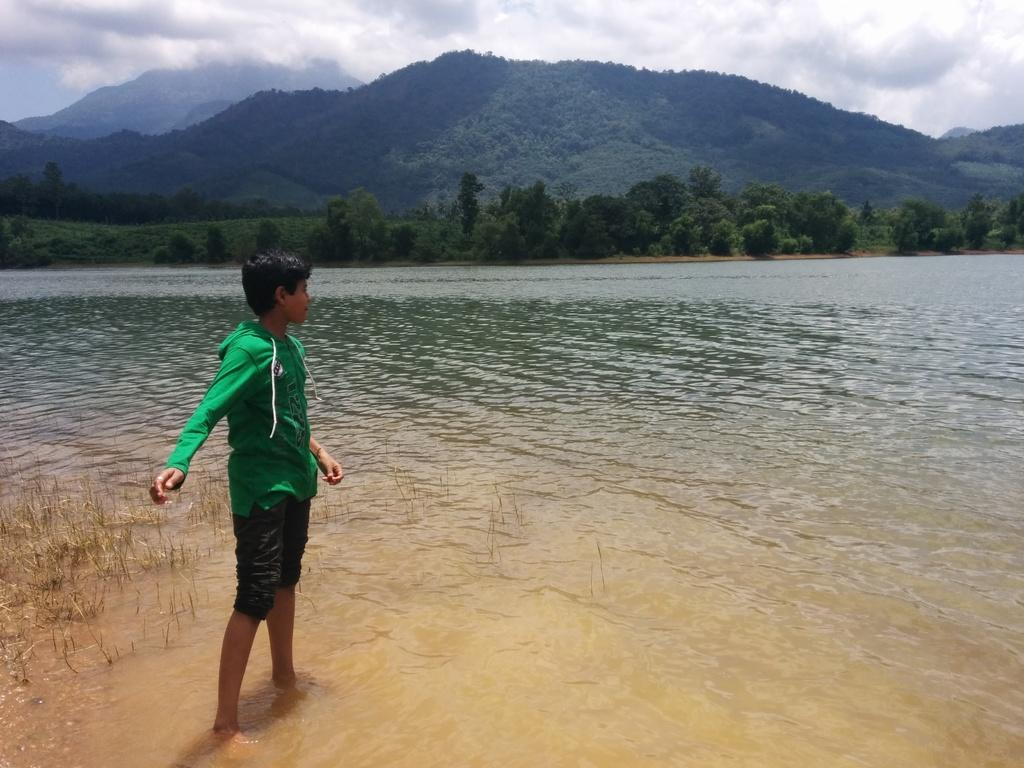What is located on the left side of the image? There is a boy on the left side of the image. What can be seen in the center of the image? There is water in the center of the image. What type of natural environment is visible in the background of the image? There are trees in the background of the image. What is the rate of the boy's care in the image? There is no indication of a rate or care in the image; it simply shows a boy on the left side, water in the center, and trees in the background. 